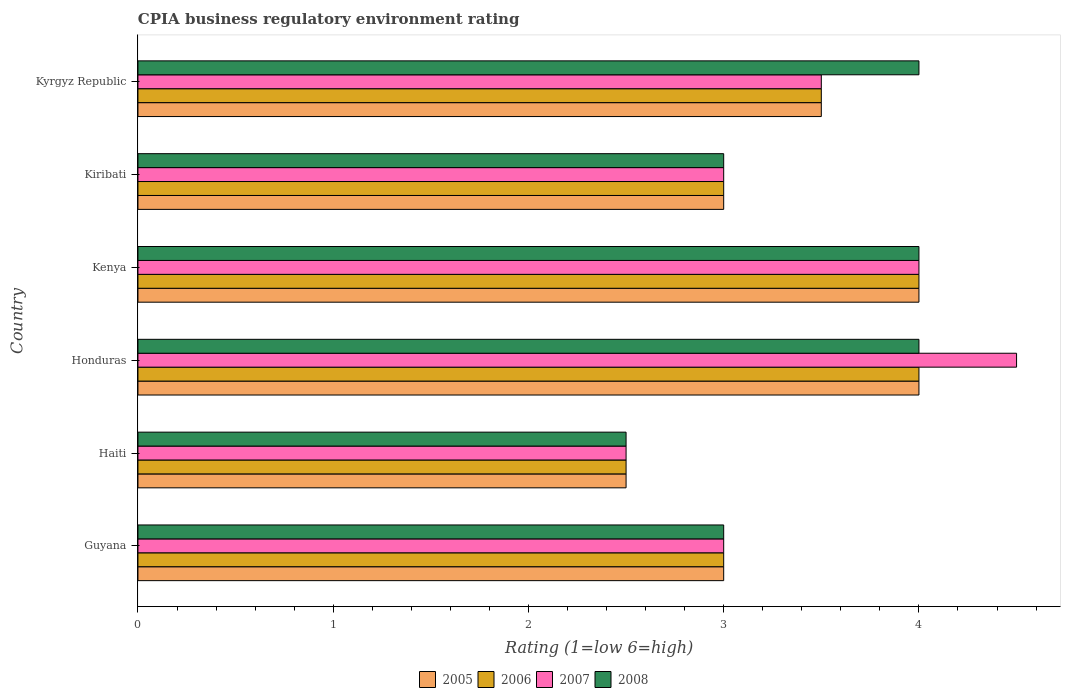How many different coloured bars are there?
Offer a very short reply. 4. Are the number of bars on each tick of the Y-axis equal?
Ensure brevity in your answer.  Yes. How many bars are there on the 4th tick from the bottom?
Provide a short and direct response. 4. What is the label of the 6th group of bars from the top?
Ensure brevity in your answer.  Guyana. What is the CPIA rating in 2005 in Kyrgyz Republic?
Your answer should be compact. 3.5. In which country was the CPIA rating in 2005 maximum?
Ensure brevity in your answer.  Honduras. In which country was the CPIA rating in 2008 minimum?
Your answer should be compact. Haiti. What is the difference between the CPIA rating in 2006 in Guyana and the CPIA rating in 2005 in Kenya?
Your response must be concise. -1. What is the average CPIA rating in 2005 per country?
Your answer should be very brief. 3.33. In how many countries, is the CPIA rating in 2006 greater than 0.2 ?
Your answer should be compact. 6. What is the difference between the highest and the second highest CPIA rating in 2005?
Ensure brevity in your answer.  0. Is the sum of the CPIA rating in 2007 in Haiti and Kyrgyz Republic greater than the maximum CPIA rating in 2008 across all countries?
Offer a very short reply. Yes. Is it the case that in every country, the sum of the CPIA rating in 2005 and CPIA rating in 2006 is greater than the sum of CPIA rating in 2007 and CPIA rating in 2008?
Ensure brevity in your answer.  No. What does the 2nd bar from the top in Kyrgyz Republic represents?
Your answer should be compact. 2007. What does the 3rd bar from the bottom in Kenya represents?
Your answer should be compact. 2007. Is it the case that in every country, the sum of the CPIA rating in 2006 and CPIA rating in 2007 is greater than the CPIA rating in 2008?
Ensure brevity in your answer.  Yes. How many countries are there in the graph?
Offer a terse response. 6. What is the difference between two consecutive major ticks on the X-axis?
Give a very brief answer. 1. Does the graph contain any zero values?
Make the answer very short. No. How many legend labels are there?
Your response must be concise. 4. How are the legend labels stacked?
Your answer should be very brief. Horizontal. What is the title of the graph?
Provide a succinct answer. CPIA business regulatory environment rating. What is the label or title of the X-axis?
Your answer should be very brief. Rating (1=low 6=high). What is the label or title of the Y-axis?
Offer a very short reply. Country. What is the Rating (1=low 6=high) in 2005 in Haiti?
Provide a short and direct response. 2.5. What is the Rating (1=low 6=high) of 2006 in Haiti?
Provide a short and direct response. 2.5. What is the Rating (1=low 6=high) of 2008 in Haiti?
Offer a terse response. 2.5. What is the Rating (1=low 6=high) of 2007 in Honduras?
Your answer should be very brief. 4.5. What is the Rating (1=low 6=high) in 2005 in Kiribati?
Keep it short and to the point. 3. What is the Rating (1=low 6=high) in 2006 in Kiribati?
Give a very brief answer. 3. What is the Rating (1=low 6=high) of 2005 in Kyrgyz Republic?
Give a very brief answer. 3.5. What is the Rating (1=low 6=high) in 2008 in Kyrgyz Republic?
Your answer should be very brief. 4. Across all countries, what is the maximum Rating (1=low 6=high) of 2006?
Offer a terse response. 4. Across all countries, what is the maximum Rating (1=low 6=high) of 2008?
Provide a short and direct response. 4. Across all countries, what is the minimum Rating (1=low 6=high) of 2005?
Keep it short and to the point. 2.5. Across all countries, what is the minimum Rating (1=low 6=high) of 2006?
Your answer should be very brief. 2.5. Across all countries, what is the minimum Rating (1=low 6=high) of 2007?
Your answer should be very brief. 2.5. Across all countries, what is the minimum Rating (1=low 6=high) in 2008?
Provide a succinct answer. 2.5. What is the total Rating (1=low 6=high) of 2005 in the graph?
Give a very brief answer. 20. What is the total Rating (1=low 6=high) in 2006 in the graph?
Give a very brief answer. 20. What is the total Rating (1=low 6=high) of 2008 in the graph?
Your response must be concise. 20.5. What is the difference between the Rating (1=low 6=high) of 2005 in Guyana and that in Haiti?
Offer a terse response. 0.5. What is the difference between the Rating (1=low 6=high) of 2006 in Guyana and that in Haiti?
Offer a very short reply. 0.5. What is the difference between the Rating (1=low 6=high) of 2008 in Guyana and that in Haiti?
Offer a terse response. 0.5. What is the difference between the Rating (1=low 6=high) of 2006 in Guyana and that in Honduras?
Offer a terse response. -1. What is the difference between the Rating (1=low 6=high) of 2007 in Guyana and that in Honduras?
Provide a succinct answer. -1.5. What is the difference between the Rating (1=low 6=high) in 2008 in Guyana and that in Honduras?
Keep it short and to the point. -1. What is the difference between the Rating (1=low 6=high) of 2006 in Guyana and that in Kenya?
Provide a succinct answer. -1. What is the difference between the Rating (1=low 6=high) of 2008 in Guyana and that in Kenya?
Make the answer very short. -1. What is the difference between the Rating (1=low 6=high) of 2005 in Guyana and that in Kiribati?
Keep it short and to the point. 0. What is the difference between the Rating (1=low 6=high) of 2006 in Guyana and that in Kiribati?
Provide a succinct answer. 0. What is the difference between the Rating (1=low 6=high) in 2007 in Guyana and that in Kyrgyz Republic?
Your answer should be compact. -0.5. What is the difference between the Rating (1=low 6=high) of 2005 in Haiti and that in Honduras?
Provide a short and direct response. -1.5. What is the difference between the Rating (1=low 6=high) of 2005 in Haiti and that in Kenya?
Provide a short and direct response. -1.5. What is the difference between the Rating (1=low 6=high) of 2008 in Haiti and that in Kenya?
Your answer should be very brief. -1.5. What is the difference between the Rating (1=low 6=high) in 2005 in Haiti and that in Kiribati?
Your answer should be compact. -0.5. What is the difference between the Rating (1=low 6=high) in 2006 in Haiti and that in Kiribati?
Offer a terse response. -0.5. What is the difference between the Rating (1=low 6=high) of 2006 in Haiti and that in Kyrgyz Republic?
Your response must be concise. -1. What is the difference between the Rating (1=low 6=high) of 2007 in Haiti and that in Kyrgyz Republic?
Your answer should be compact. -1. What is the difference between the Rating (1=low 6=high) in 2006 in Honduras and that in Kenya?
Ensure brevity in your answer.  0. What is the difference between the Rating (1=low 6=high) in 2008 in Honduras and that in Kenya?
Keep it short and to the point. 0. What is the difference between the Rating (1=low 6=high) of 2005 in Honduras and that in Kiribati?
Provide a succinct answer. 1. What is the difference between the Rating (1=low 6=high) of 2007 in Honduras and that in Kiribati?
Ensure brevity in your answer.  1.5. What is the difference between the Rating (1=low 6=high) of 2008 in Honduras and that in Kiribati?
Provide a short and direct response. 1. What is the difference between the Rating (1=low 6=high) in 2006 in Honduras and that in Kyrgyz Republic?
Your response must be concise. 0.5. What is the difference between the Rating (1=low 6=high) of 2007 in Honduras and that in Kyrgyz Republic?
Your answer should be compact. 1. What is the difference between the Rating (1=low 6=high) of 2008 in Honduras and that in Kyrgyz Republic?
Give a very brief answer. 0. What is the difference between the Rating (1=low 6=high) in 2005 in Kenya and that in Kiribati?
Your response must be concise. 1. What is the difference between the Rating (1=low 6=high) of 2005 in Kenya and that in Kyrgyz Republic?
Give a very brief answer. 0.5. What is the difference between the Rating (1=low 6=high) in 2007 in Kiribati and that in Kyrgyz Republic?
Keep it short and to the point. -0.5. What is the difference between the Rating (1=low 6=high) in 2005 in Guyana and the Rating (1=low 6=high) in 2007 in Haiti?
Provide a succinct answer. 0.5. What is the difference between the Rating (1=low 6=high) of 2005 in Guyana and the Rating (1=low 6=high) of 2008 in Haiti?
Your answer should be compact. 0.5. What is the difference between the Rating (1=low 6=high) of 2006 in Guyana and the Rating (1=low 6=high) of 2007 in Haiti?
Ensure brevity in your answer.  0.5. What is the difference between the Rating (1=low 6=high) in 2007 in Guyana and the Rating (1=low 6=high) in 2008 in Haiti?
Your response must be concise. 0.5. What is the difference between the Rating (1=low 6=high) in 2005 in Guyana and the Rating (1=low 6=high) in 2006 in Honduras?
Offer a terse response. -1. What is the difference between the Rating (1=low 6=high) in 2005 in Guyana and the Rating (1=low 6=high) in 2007 in Honduras?
Keep it short and to the point. -1.5. What is the difference between the Rating (1=low 6=high) of 2005 in Guyana and the Rating (1=low 6=high) of 2008 in Honduras?
Your answer should be compact. -1. What is the difference between the Rating (1=low 6=high) of 2006 in Guyana and the Rating (1=low 6=high) of 2007 in Honduras?
Offer a terse response. -1.5. What is the difference between the Rating (1=low 6=high) in 2007 in Guyana and the Rating (1=low 6=high) in 2008 in Honduras?
Provide a short and direct response. -1. What is the difference between the Rating (1=low 6=high) of 2005 in Guyana and the Rating (1=low 6=high) of 2006 in Kenya?
Your answer should be very brief. -1. What is the difference between the Rating (1=low 6=high) of 2005 in Guyana and the Rating (1=low 6=high) of 2007 in Kenya?
Ensure brevity in your answer.  -1. What is the difference between the Rating (1=low 6=high) of 2006 in Guyana and the Rating (1=low 6=high) of 2007 in Kenya?
Provide a succinct answer. -1. What is the difference between the Rating (1=low 6=high) in 2007 in Guyana and the Rating (1=low 6=high) in 2008 in Kenya?
Make the answer very short. -1. What is the difference between the Rating (1=low 6=high) in 2005 in Guyana and the Rating (1=low 6=high) in 2006 in Kiribati?
Give a very brief answer. 0. What is the difference between the Rating (1=low 6=high) in 2006 in Guyana and the Rating (1=low 6=high) in 2007 in Kiribati?
Offer a terse response. 0. What is the difference between the Rating (1=low 6=high) in 2006 in Guyana and the Rating (1=low 6=high) in 2008 in Kiribati?
Your answer should be very brief. 0. What is the difference between the Rating (1=low 6=high) of 2007 in Guyana and the Rating (1=low 6=high) of 2008 in Kiribati?
Offer a very short reply. 0. What is the difference between the Rating (1=low 6=high) of 2005 in Guyana and the Rating (1=low 6=high) of 2007 in Kyrgyz Republic?
Make the answer very short. -0.5. What is the difference between the Rating (1=low 6=high) in 2005 in Guyana and the Rating (1=low 6=high) in 2008 in Kyrgyz Republic?
Provide a short and direct response. -1. What is the difference between the Rating (1=low 6=high) of 2006 in Guyana and the Rating (1=low 6=high) of 2007 in Kyrgyz Republic?
Your answer should be compact. -0.5. What is the difference between the Rating (1=low 6=high) in 2005 in Haiti and the Rating (1=low 6=high) in 2006 in Honduras?
Keep it short and to the point. -1.5. What is the difference between the Rating (1=low 6=high) in 2005 in Haiti and the Rating (1=low 6=high) in 2007 in Honduras?
Make the answer very short. -2. What is the difference between the Rating (1=low 6=high) of 2006 in Haiti and the Rating (1=low 6=high) of 2007 in Honduras?
Your answer should be very brief. -2. What is the difference between the Rating (1=low 6=high) in 2006 in Haiti and the Rating (1=low 6=high) in 2008 in Honduras?
Your response must be concise. -1.5. What is the difference between the Rating (1=low 6=high) of 2007 in Haiti and the Rating (1=low 6=high) of 2008 in Honduras?
Offer a terse response. -1.5. What is the difference between the Rating (1=low 6=high) in 2005 in Haiti and the Rating (1=low 6=high) in 2006 in Kenya?
Give a very brief answer. -1.5. What is the difference between the Rating (1=low 6=high) of 2005 in Haiti and the Rating (1=low 6=high) of 2008 in Kenya?
Provide a succinct answer. -1.5. What is the difference between the Rating (1=low 6=high) of 2006 in Haiti and the Rating (1=low 6=high) of 2007 in Kenya?
Make the answer very short. -1.5. What is the difference between the Rating (1=low 6=high) in 2006 in Haiti and the Rating (1=low 6=high) in 2008 in Kenya?
Make the answer very short. -1.5. What is the difference between the Rating (1=low 6=high) of 2005 in Haiti and the Rating (1=low 6=high) of 2006 in Kiribati?
Provide a succinct answer. -0.5. What is the difference between the Rating (1=low 6=high) in 2005 in Haiti and the Rating (1=low 6=high) in 2007 in Kiribati?
Make the answer very short. -0.5. What is the difference between the Rating (1=low 6=high) of 2006 in Haiti and the Rating (1=low 6=high) of 2007 in Kiribati?
Ensure brevity in your answer.  -0.5. What is the difference between the Rating (1=low 6=high) of 2006 in Haiti and the Rating (1=low 6=high) of 2008 in Kiribati?
Give a very brief answer. -0.5. What is the difference between the Rating (1=low 6=high) of 2005 in Haiti and the Rating (1=low 6=high) of 2008 in Kyrgyz Republic?
Your answer should be very brief. -1.5. What is the difference between the Rating (1=low 6=high) in 2006 in Haiti and the Rating (1=low 6=high) in 2008 in Kyrgyz Republic?
Make the answer very short. -1.5. What is the difference between the Rating (1=low 6=high) of 2007 in Haiti and the Rating (1=low 6=high) of 2008 in Kyrgyz Republic?
Ensure brevity in your answer.  -1.5. What is the difference between the Rating (1=low 6=high) in 2005 in Honduras and the Rating (1=low 6=high) in 2008 in Kenya?
Provide a succinct answer. 0. What is the difference between the Rating (1=low 6=high) in 2006 in Honduras and the Rating (1=low 6=high) in 2008 in Kenya?
Keep it short and to the point. 0. What is the difference between the Rating (1=low 6=high) of 2007 in Honduras and the Rating (1=low 6=high) of 2008 in Kenya?
Offer a terse response. 0.5. What is the difference between the Rating (1=low 6=high) of 2006 in Honduras and the Rating (1=low 6=high) of 2007 in Kiribati?
Provide a short and direct response. 1. What is the difference between the Rating (1=low 6=high) in 2005 in Honduras and the Rating (1=low 6=high) in 2007 in Kyrgyz Republic?
Keep it short and to the point. 0.5. What is the difference between the Rating (1=low 6=high) in 2006 in Honduras and the Rating (1=low 6=high) in 2007 in Kyrgyz Republic?
Offer a very short reply. 0.5. What is the difference between the Rating (1=low 6=high) in 2006 in Kenya and the Rating (1=low 6=high) in 2008 in Kiribati?
Your response must be concise. 1. What is the difference between the Rating (1=low 6=high) in 2005 in Kenya and the Rating (1=low 6=high) in 2007 in Kyrgyz Republic?
Offer a terse response. 0.5. What is the difference between the Rating (1=low 6=high) of 2005 in Kiribati and the Rating (1=low 6=high) of 2007 in Kyrgyz Republic?
Provide a short and direct response. -0.5. What is the difference between the Rating (1=low 6=high) in 2006 in Kiribati and the Rating (1=low 6=high) in 2007 in Kyrgyz Republic?
Your answer should be compact. -0.5. What is the difference between the Rating (1=low 6=high) of 2006 in Kiribati and the Rating (1=low 6=high) of 2008 in Kyrgyz Republic?
Your answer should be compact. -1. What is the difference between the Rating (1=low 6=high) of 2007 in Kiribati and the Rating (1=low 6=high) of 2008 in Kyrgyz Republic?
Keep it short and to the point. -1. What is the average Rating (1=low 6=high) in 2005 per country?
Keep it short and to the point. 3.33. What is the average Rating (1=low 6=high) in 2006 per country?
Offer a very short reply. 3.33. What is the average Rating (1=low 6=high) in 2007 per country?
Ensure brevity in your answer.  3.42. What is the average Rating (1=low 6=high) of 2008 per country?
Make the answer very short. 3.42. What is the difference between the Rating (1=low 6=high) in 2005 and Rating (1=low 6=high) in 2006 in Guyana?
Provide a succinct answer. 0. What is the difference between the Rating (1=low 6=high) of 2005 and Rating (1=low 6=high) of 2007 in Guyana?
Provide a succinct answer. 0. What is the difference between the Rating (1=low 6=high) in 2005 and Rating (1=low 6=high) in 2008 in Guyana?
Ensure brevity in your answer.  0. What is the difference between the Rating (1=low 6=high) of 2006 and Rating (1=low 6=high) of 2008 in Guyana?
Provide a succinct answer. 0. What is the difference between the Rating (1=low 6=high) of 2007 and Rating (1=low 6=high) of 2008 in Guyana?
Provide a succinct answer. 0. What is the difference between the Rating (1=low 6=high) of 2005 and Rating (1=low 6=high) of 2007 in Haiti?
Make the answer very short. 0. What is the difference between the Rating (1=low 6=high) of 2006 and Rating (1=low 6=high) of 2007 in Haiti?
Give a very brief answer. 0. What is the difference between the Rating (1=low 6=high) of 2007 and Rating (1=low 6=high) of 2008 in Haiti?
Give a very brief answer. 0. What is the difference between the Rating (1=low 6=high) of 2005 and Rating (1=low 6=high) of 2006 in Honduras?
Your answer should be compact. 0. What is the difference between the Rating (1=low 6=high) in 2005 and Rating (1=low 6=high) in 2008 in Honduras?
Provide a short and direct response. 0. What is the difference between the Rating (1=low 6=high) in 2006 and Rating (1=low 6=high) in 2008 in Honduras?
Provide a short and direct response. 0. What is the difference between the Rating (1=low 6=high) in 2005 and Rating (1=low 6=high) in 2008 in Kenya?
Provide a succinct answer. 0. What is the difference between the Rating (1=low 6=high) of 2007 and Rating (1=low 6=high) of 2008 in Kenya?
Offer a terse response. 0. What is the difference between the Rating (1=low 6=high) of 2005 and Rating (1=low 6=high) of 2008 in Kiribati?
Provide a succinct answer. 0. What is the difference between the Rating (1=low 6=high) in 2006 and Rating (1=low 6=high) in 2008 in Kiribati?
Your response must be concise. 0. What is the difference between the Rating (1=low 6=high) of 2007 and Rating (1=low 6=high) of 2008 in Kiribati?
Keep it short and to the point. 0. What is the difference between the Rating (1=low 6=high) of 2005 and Rating (1=low 6=high) of 2006 in Kyrgyz Republic?
Offer a very short reply. 0. What is the difference between the Rating (1=low 6=high) in 2005 and Rating (1=low 6=high) in 2007 in Kyrgyz Republic?
Give a very brief answer. 0. What is the difference between the Rating (1=low 6=high) of 2006 and Rating (1=low 6=high) of 2007 in Kyrgyz Republic?
Make the answer very short. 0. What is the difference between the Rating (1=low 6=high) in 2006 and Rating (1=low 6=high) in 2008 in Kyrgyz Republic?
Your response must be concise. -0.5. What is the difference between the Rating (1=low 6=high) of 2007 and Rating (1=low 6=high) of 2008 in Kyrgyz Republic?
Give a very brief answer. -0.5. What is the ratio of the Rating (1=low 6=high) in 2005 in Guyana to that in Haiti?
Your response must be concise. 1.2. What is the ratio of the Rating (1=low 6=high) of 2007 in Guyana to that in Haiti?
Your answer should be compact. 1.2. What is the ratio of the Rating (1=low 6=high) of 2008 in Guyana to that in Haiti?
Provide a short and direct response. 1.2. What is the ratio of the Rating (1=low 6=high) in 2005 in Guyana to that in Honduras?
Make the answer very short. 0.75. What is the ratio of the Rating (1=low 6=high) of 2006 in Guyana to that in Honduras?
Your answer should be compact. 0.75. What is the ratio of the Rating (1=low 6=high) in 2008 in Guyana to that in Honduras?
Provide a succinct answer. 0.75. What is the ratio of the Rating (1=low 6=high) in 2005 in Guyana to that in Kenya?
Offer a very short reply. 0.75. What is the ratio of the Rating (1=low 6=high) in 2006 in Guyana to that in Kenya?
Provide a short and direct response. 0.75. What is the ratio of the Rating (1=low 6=high) of 2008 in Guyana to that in Kenya?
Your answer should be very brief. 0.75. What is the ratio of the Rating (1=low 6=high) in 2005 in Guyana to that in Kyrgyz Republic?
Your answer should be compact. 0.86. What is the ratio of the Rating (1=low 6=high) in 2006 in Guyana to that in Kyrgyz Republic?
Your response must be concise. 0.86. What is the ratio of the Rating (1=low 6=high) in 2007 in Guyana to that in Kyrgyz Republic?
Offer a very short reply. 0.86. What is the ratio of the Rating (1=low 6=high) in 2005 in Haiti to that in Honduras?
Offer a terse response. 0.62. What is the ratio of the Rating (1=low 6=high) in 2007 in Haiti to that in Honduras?
Your response must be concise. 0.56. What is the ratio of the Rating (1=low 6=high) in 2006 in Haiti to that in Kenya?
Provide a succinct answer. 0.62. What is the ratio of the Rating (1=low 6=high) of 2008 in Haiti to that in Kenya?
Your answer should be very brief. 0.62. What is the ratio of the Rating (1=low 6=high) in 2006 in Haiti to that in Kiribati?
Your response must be concise. 0.83. What is the ratio of the Rating (1=low 6=high) in 2008 in Haiti to that in Kiribati?
Provide a succinct answer. 0.83. What is the ratio of the Rating (1=low 6=high) in 2005 in Honduras to that in Kenya?
Your answer should be compact. 1. What is the ratio of the Rating (1=low 6=high) of 2008 in Honduras to that in Kenya?
Your answer should be very brief. 1. What is the ratio of the Rating (1=low 6=high) in 2008 in Honduras to that in Kiribati?
Your answer should be compact. 1.33. What is the ratio of the Rating (1=low 6=high) in 2006 in Honduras to that in Kyrgyz Republic?
Your response must be concise. 1.14. What is the ratio of the Rating (1=low 6=high) in 2008 in Honduras to that in Kyrgyz Republic?
Your answer should be very brief. 1. What is the ratio of the Rating (1=low 6=high) of 2005 in Kenya to that in Kiribati?
Provide a succinct answer. 1.33. What is the ratio of the Rating (1=low 6=high) in 2006 in Kenya to that in Kiribati?
Make the answer very short. 1.33. What is the ratio of the Rating (1=low 6=high) in 2007 in Kenya to that in Kiribati?
Make the answer very short. 1.33. What is the ratio of the Rating (1=low 6=high) in 2008 in Kenya to that in Kiribati?
Make the answer very short. 1.33. What is the ratio of the Rating (1=low 6=high) of 2005 in Kenya to that in Kyrgyz Republic?
Offer a terse response. 1.14. What is the ratio of the Rating (1=low 6=high) in 2006 in Kenya to that in Kyrgyz Republic?
Ensure brevity in your answer.  1.14. What is the ratio of the Rating (1=low 6=high) of 2008 in Kiribati to that in Kyrgyz Republic?
Ensure brevity in your answer.  0.75. What is the difference between the highest and the second highest Rating (1=low 6=high) of 2006?
Offer a very short reply. 0. What is the difference between the highest and the lowest Rating (1=low 6=high) in 2005?
Ensure brevity in your answer.  1.5. 